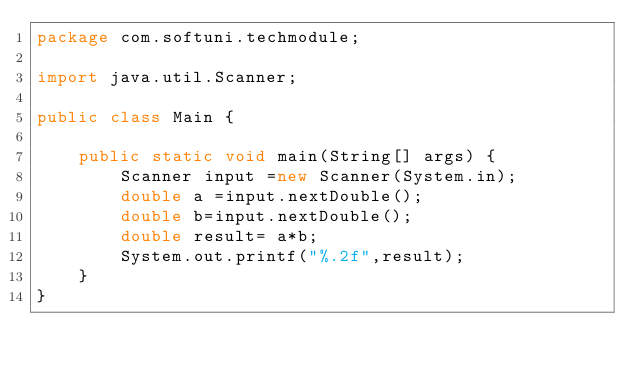Convert code to text. <code><loc_0><loc_0><loc_500><loc_500><_Java_>package com.softuni.techmodule;

import java.util.Scanner;

public class Main {

    public static void main(String[] args) {
        Scanner input =new Scanner(System.in);
        double a =input.nextDouble();
        double b=input.nextDouble();
        double result= a*b;
        System.out.printf("%.2f",result);
    }
}
</code> 